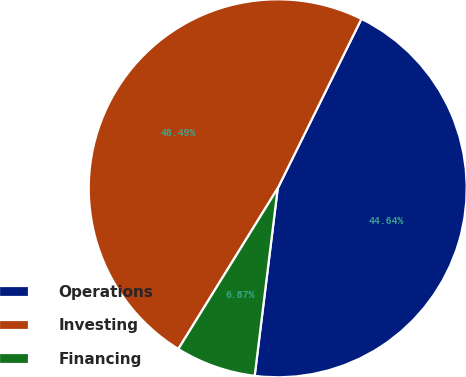Convert chart to OTSL. <chart><loc_0><loc_0><loc_500><loc_500><pie_chart><fcel>Operations<fcel>Investing<fcel>Financing<nl><fcel>44.64%<fcel>48.49%<fcel>6.87%<nl></chart> 